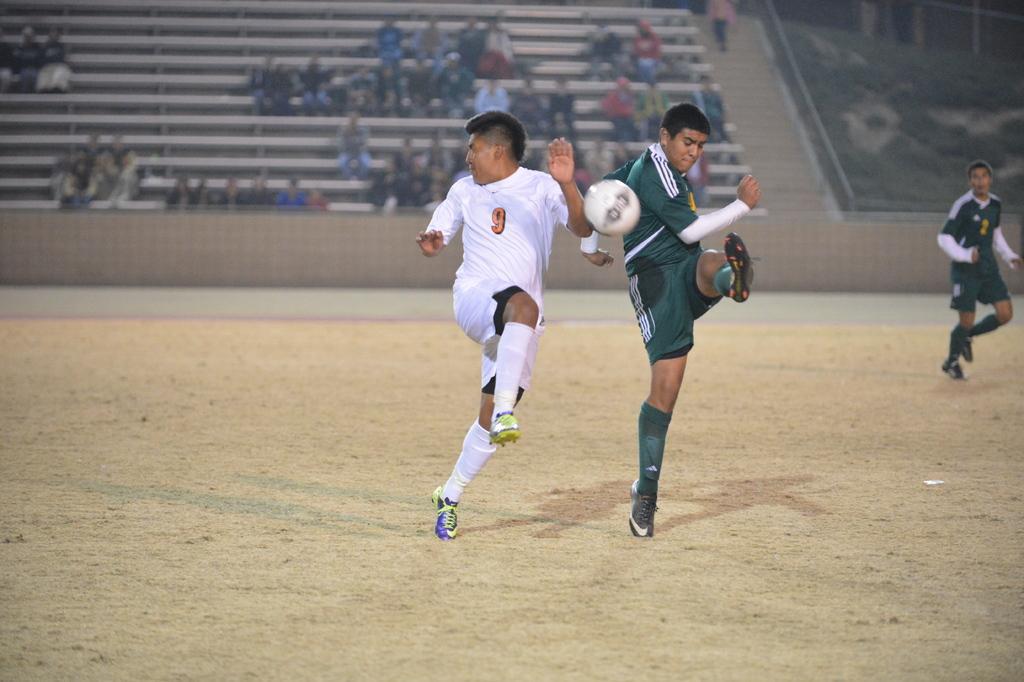Please provide a concise description of this image. The image is in the ground. there are players playing football. In the middle one player is wearing white jersey. Beside him one player is wearing green jersey. He is in position of kicking the ball. Alright in the right side is wearing green jersey. He is in a running position. in the background there is gallery. In the right top corner there are grasses. 